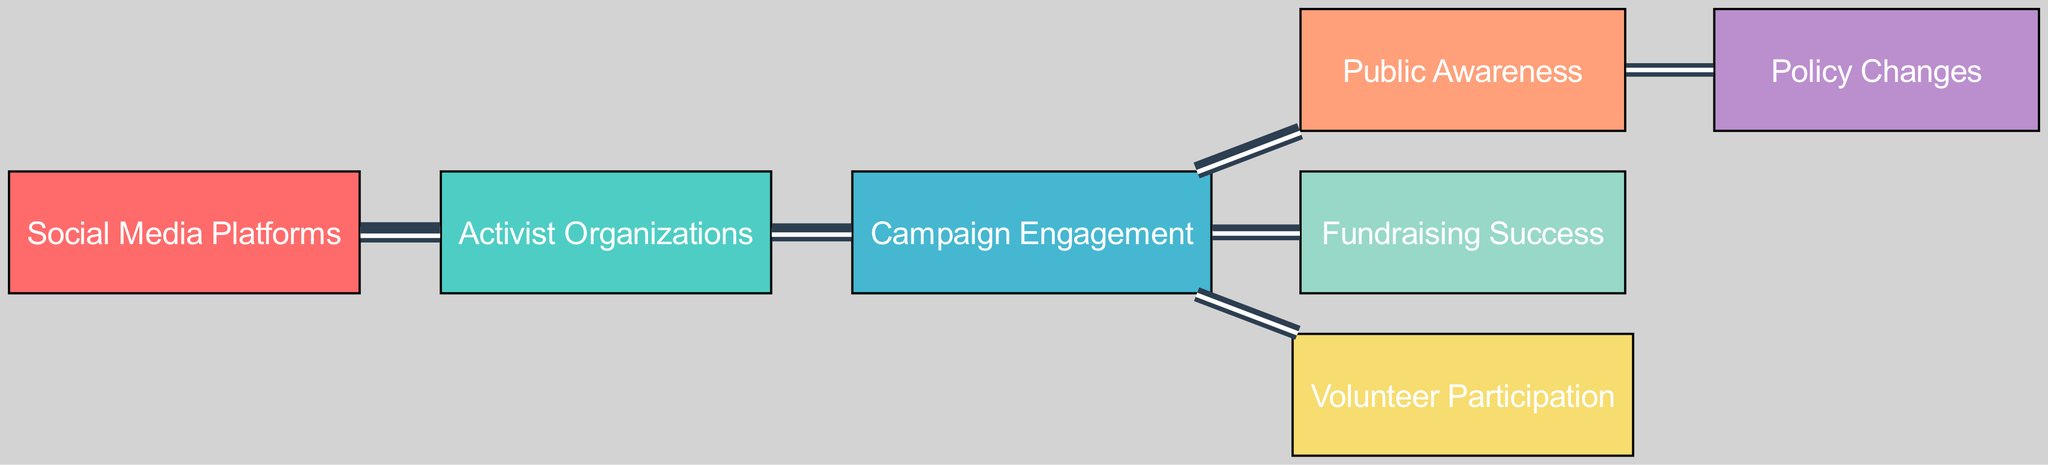What is the total number of nodes in the diagram? The diagram lists six unique entities representing different components of the campaigns, counted directly from the nodes section.
Answer: 6 Which node has the highest number of connections? By examining the links section, "Campaign Engagement" connects to three nodes: Public Awareness, Fundraising Success, and Volunteer Participation, which is the most among all nodes.
Answer: Campaign Engagement What is the value of the connection between "Social Media Platforms" and "Activist Organizations"? The value of this connection is noted in the links section and is specified as 10, indicating the strength of the flow from Social Media Platforms to Activist Organizations.
Answer: 10 How many connections does "Public Awareness" have? "Public Awareness" receives input from "Campaign Engagement" and provides output to "Policy Changes," totaling two connections when counted in the edges section.
Answer: 2 What is the value of the flow from "Campaign Engagement" to "Volunteer Participation"? The value for this flow, as indicated in the links section, is 5, representing how impactful the campaign engagement is on volunteer participation.
Answer: 5 Which outcome receives the least value from "Campaign Engagement"? The connection to "Volunteer Participation" from "Campaign Engagement" has the lowest value of 5 when compared to other outcomes, making it the least impactful of the three.
Answer: Volunteer Participation How does increased Public Awareness relate to Policy Changes in terms of value? The connection shows that increased Public Awareness has a value of 4 directed towards Policy Changes, indicating a positive impact that the previous node directly influences.
Answer: 4 What is the total value flowing from "Campaign Engagement" to outcomes? To get this, we sum the values of the three connections from "Campaign Engagement": Fundraising Success (6), Volunteer Participation (5), and Public Awareness (7), reaching a total of 18.
Answer: 18 Which node directly impacts Fundraising Success? The link from "Campaign Engagement" to "Fundraising Success" is the only connection affecting it directly, showing it as the impacting node.
Answer: Campaign Engagement 